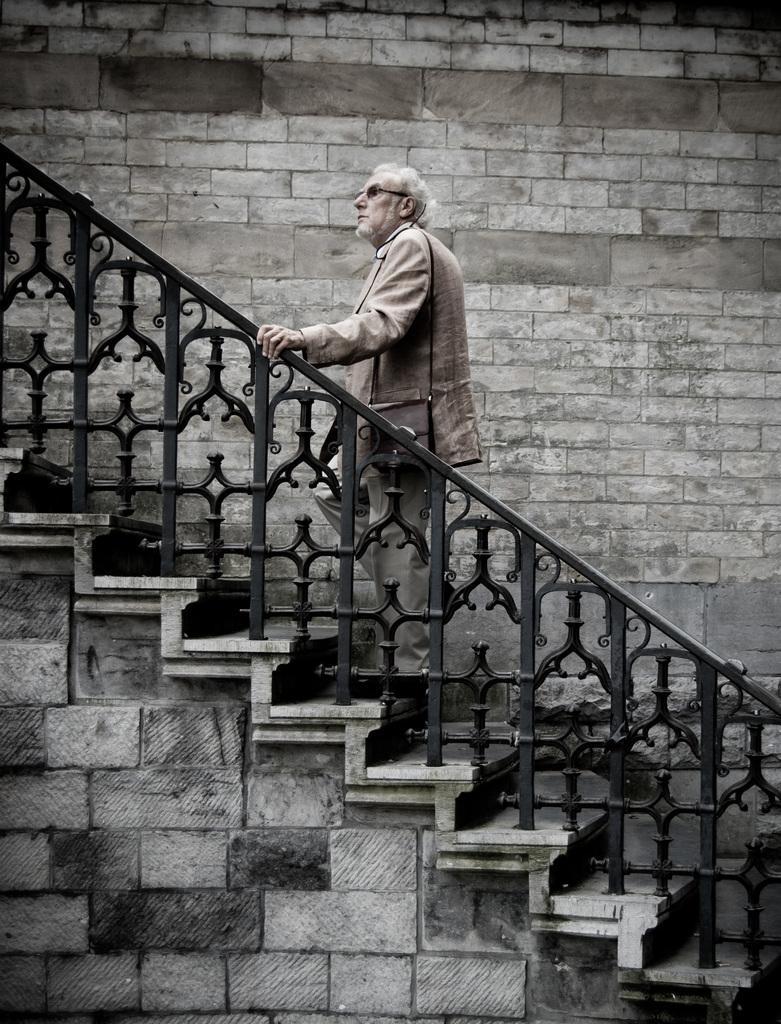Can you describe this image briefly? An old man is walking through the steps. This is a stone wall in the middle of an image. 